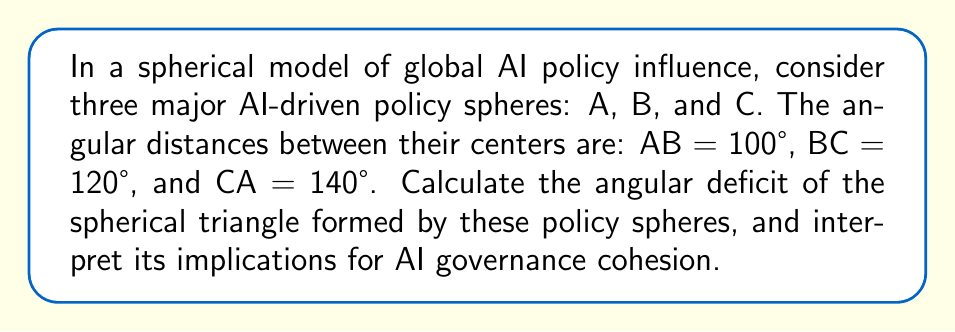Solve this math problem. To solve this problem, we'll use concepts from spherical geometry:

1) In spherical geometry, the sum of angles in a triangle is always greater than 180°. The difference between this sum and 180° is called the angular deficit.

2) Let's denote the angles of the spherical triangle as α, β, and γ.

3) The formula for the angular deficit (E) is:

   $$ E = \alpha + \beta + \gamma - 180° $$

4) To find these angles, we can use the spherical law of cosines:

   $$ \cos(a) = \cos(b)\cos(c) + \sin(b)\sin(c)\cos(A) $$

   Where a, b, and c are the side lengths (in our case, the angular distances), and A is the angle opposite to side a.

5) Let's calculate each angle:

   For α (opposite to BC):
   $$ \cos(120°) = \cos(100°)\cos(140°) + \sin(100°)\sin(140°)\cos(\alpha) $$
   $$ \cos(\alpha) = \frac{\cos(120°) - \cos(100°)\cos(140°)}{\sin(100°)\sin(140°)} $$
   $$ \alpha \approx 77.18° $$

   Similarly, for β and γ:
   $$ β \approx 53.13° $$
   $$ γ \approx 93.17° $$

6) Now we can calculate the angular deficit:

   $$ E = 77.18° + 53.13° + 93.17° - 180° = 43.48° $$

7) Interpretation: The angular deficit of 43.48° suggests a significant departure from Euclidean geometry, indicating complex interactions between AI policy spheres. A larger deficit implies more curvature in the policy space, potentially representing greater complexity and interdependence in AI governance.
Answer: 43.48°; higher angular deficit indicates increased complexity in AI governance interactions. 